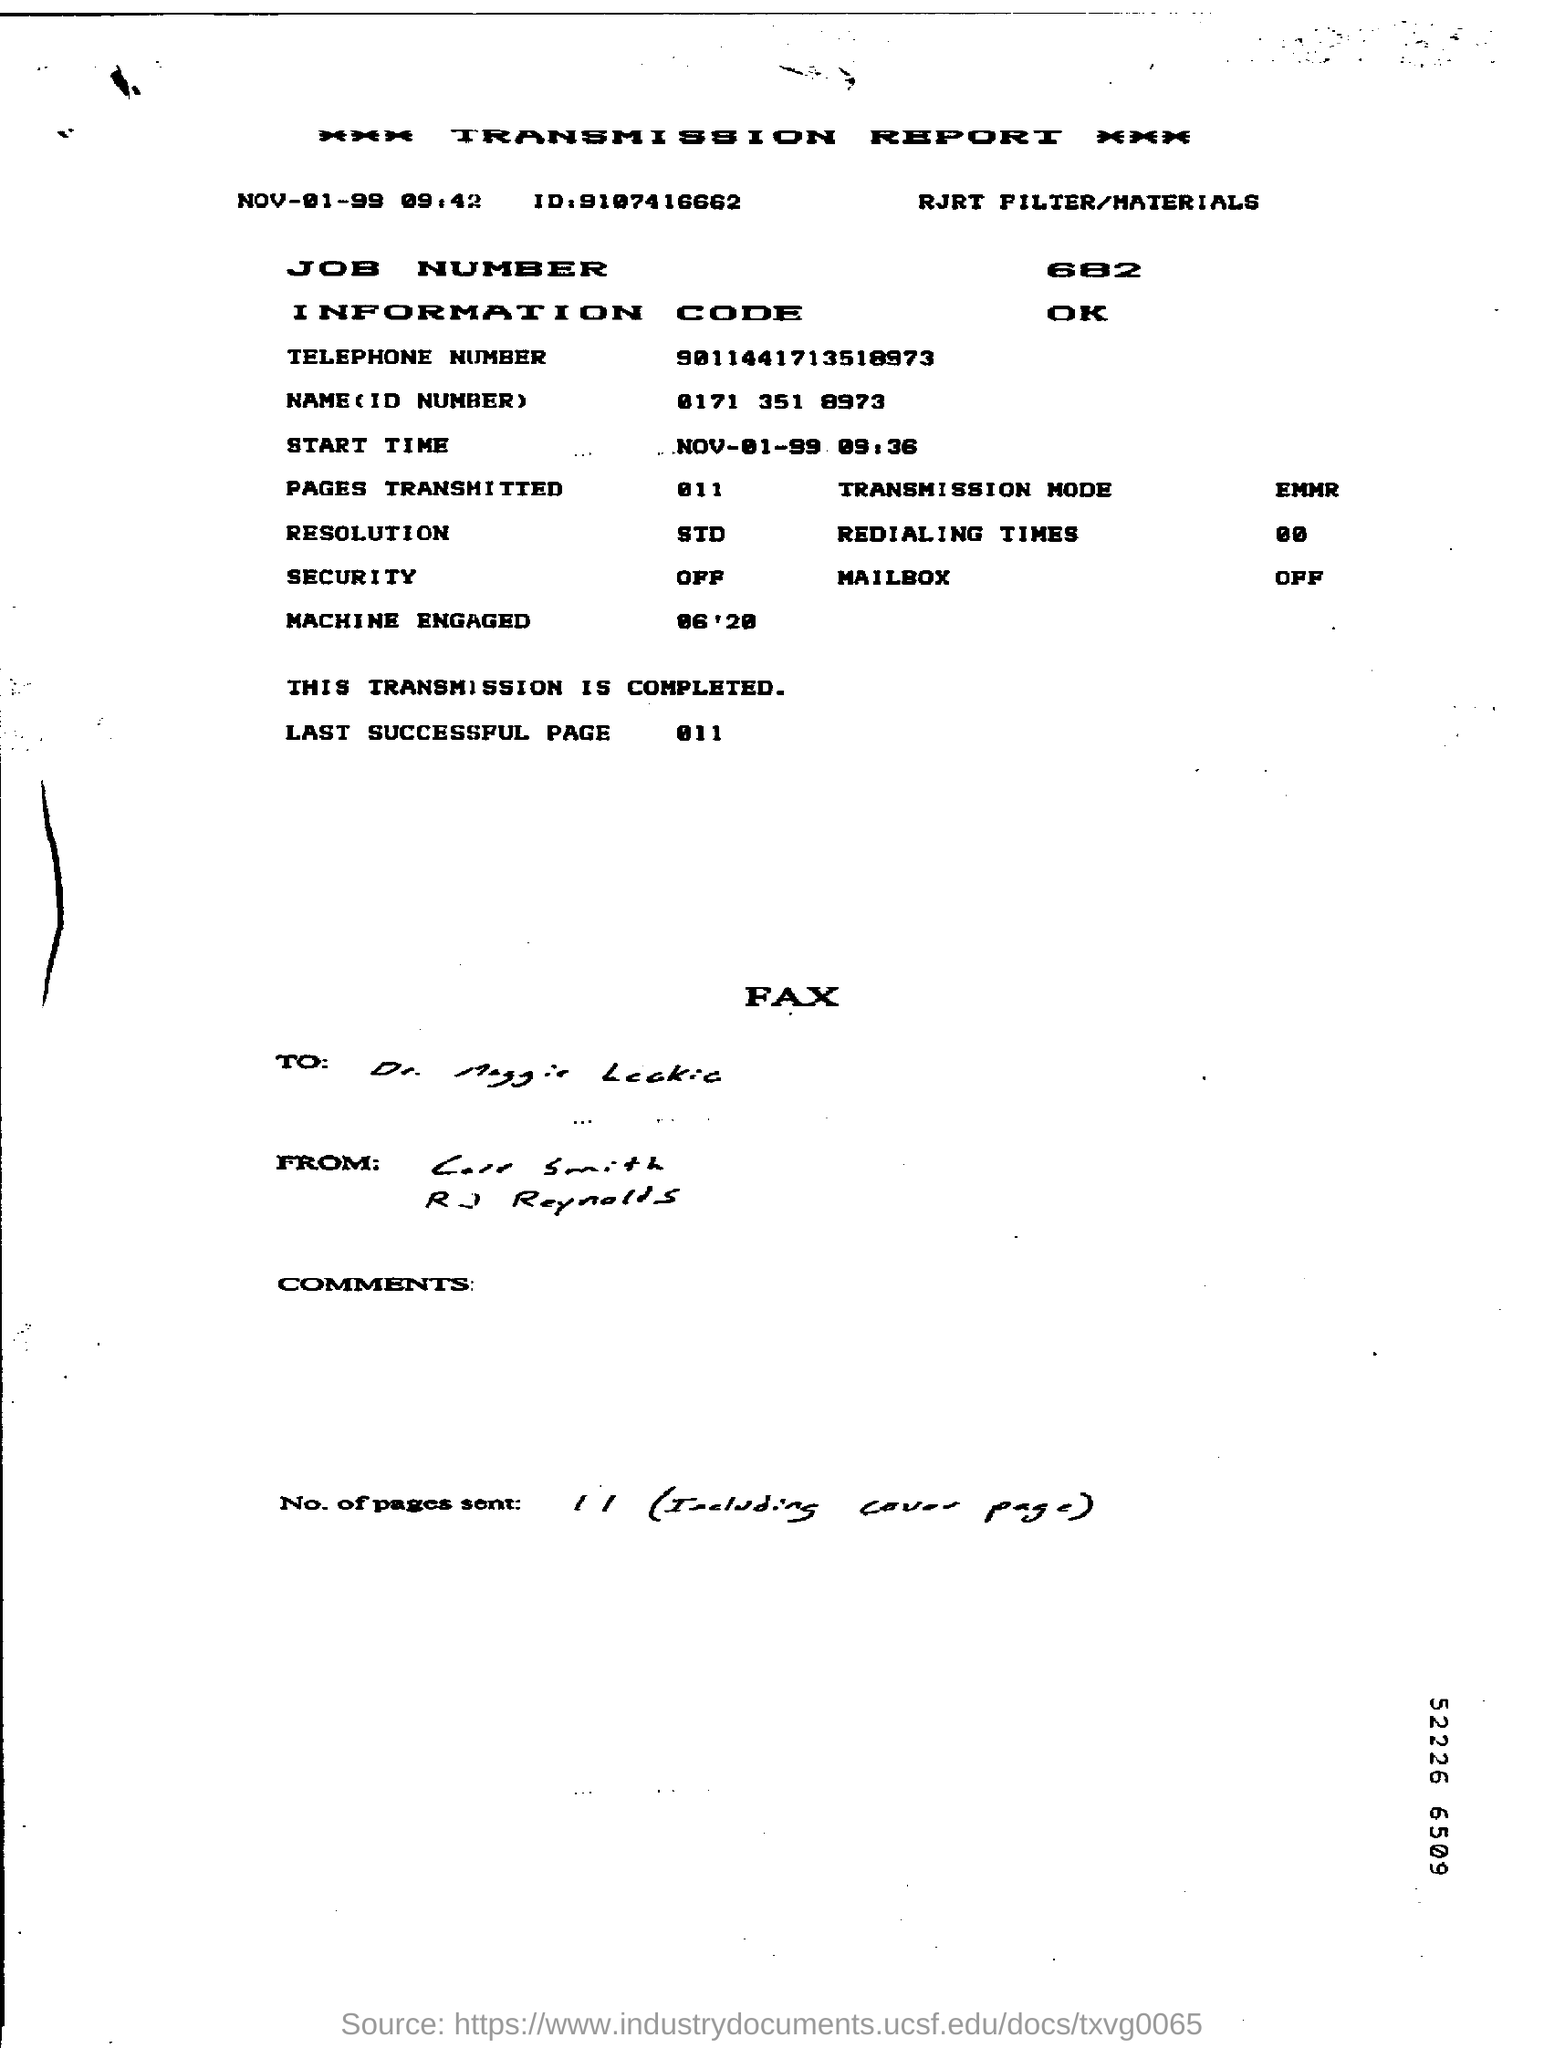What is the Start time mentioned in the transmission report?
Provide a short and direct response. NOV-01-99     09:36. What is the job number given?
Ensure brevity in your answer.  682. What is the information code mentioned ?
Make the answer very short. OK. What is the transmission mode mentioned in the report?
Your answer should be compact. EMMR. What is the telephone number mentioned in the report?
Provide a short and direct response. 9011441713518973. 